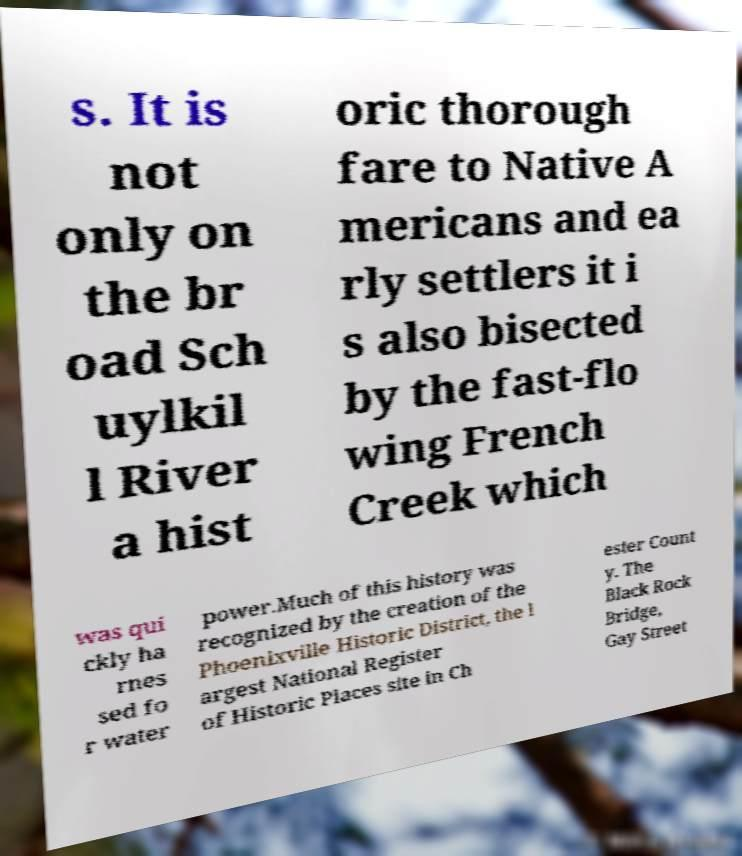For documentation purposes, I need the text within this image transcribed. Could you provide that? s. It is not only on the br oad Sch uylkil l River a hist oric thorough fare to Native A mericans and ea rly settlers it i s also bisected by the fast-flo wing French Creek which was qui ckly ha rnes sed fo r water power.Much of this history was recognized by the creation of the Phoenixville Historic District, the l argest National Register of Historic Places site in Ch ester Count y. The Black Rock Bridge, Gay Street 